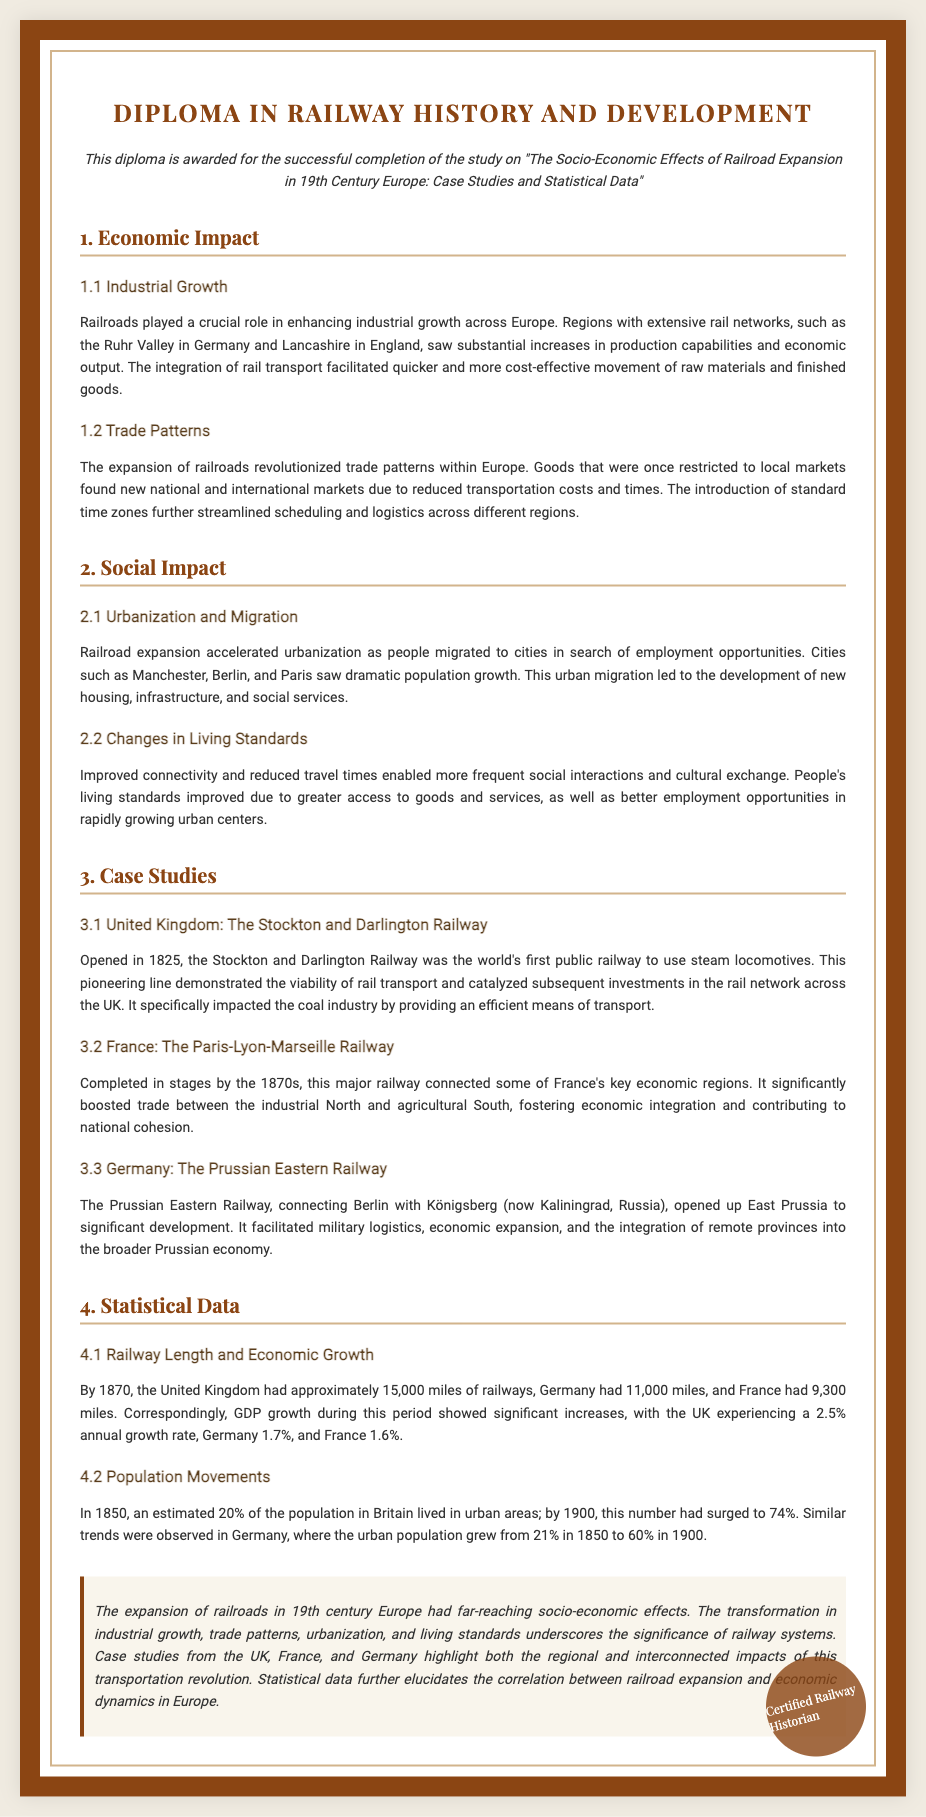What role did railroads play in industrial growth? Railroads played a crucial role in enhancing industrial growth across Europe by increasing production capabilities and economic output.
Answer: crucial role What significant population change occurred in Britain from 1850 to 1900? In 1850, an estimated 20% of the population in Britain lived in urban areas; by 1900, this number had surged to 74%.
Answer: surged to 74% What was the first public railway to use steam locomotives? The Stockton and Darlington Railway was the world's first public railway to use steam locomotives.
Answer: Stockton and Darlington Railway Which country's railway connected the industrial North and agricultural South? The Paris-Lyon-Marseille Railway significantly boosted trade between the industrial North and agricultural South in France.
Answer: France What was the GDP growth rate for the UK during this period? The UK experienced a 2.5% annual growth rate during this period.
Answer: 2.5% How did the expansion of railroads affect trade patterns? The expansion of railroads revolutionized trade patterns within Europe by reducing transportation costs and times, allowing goods to reach national and international markets.
Answer: revolutionized trade patterns What were the approximate railway miles in Germany by 1870? By 1870, Germany had approximately 11,000 miles of railways.
Answer: 11,000 miles What does this diploma certify the recipient as? The diploma certifies the recipient as a "Certified Railway Historian."
Answer: Certified Railway Historian Which city saw significant population growth due to urbanization from rail expansion? Cities such as Manchester, Berlin, and Paris saw dramatic population growth due to urbanization from rail expansion.
Answer: Manchester, Berlin, and Paris 